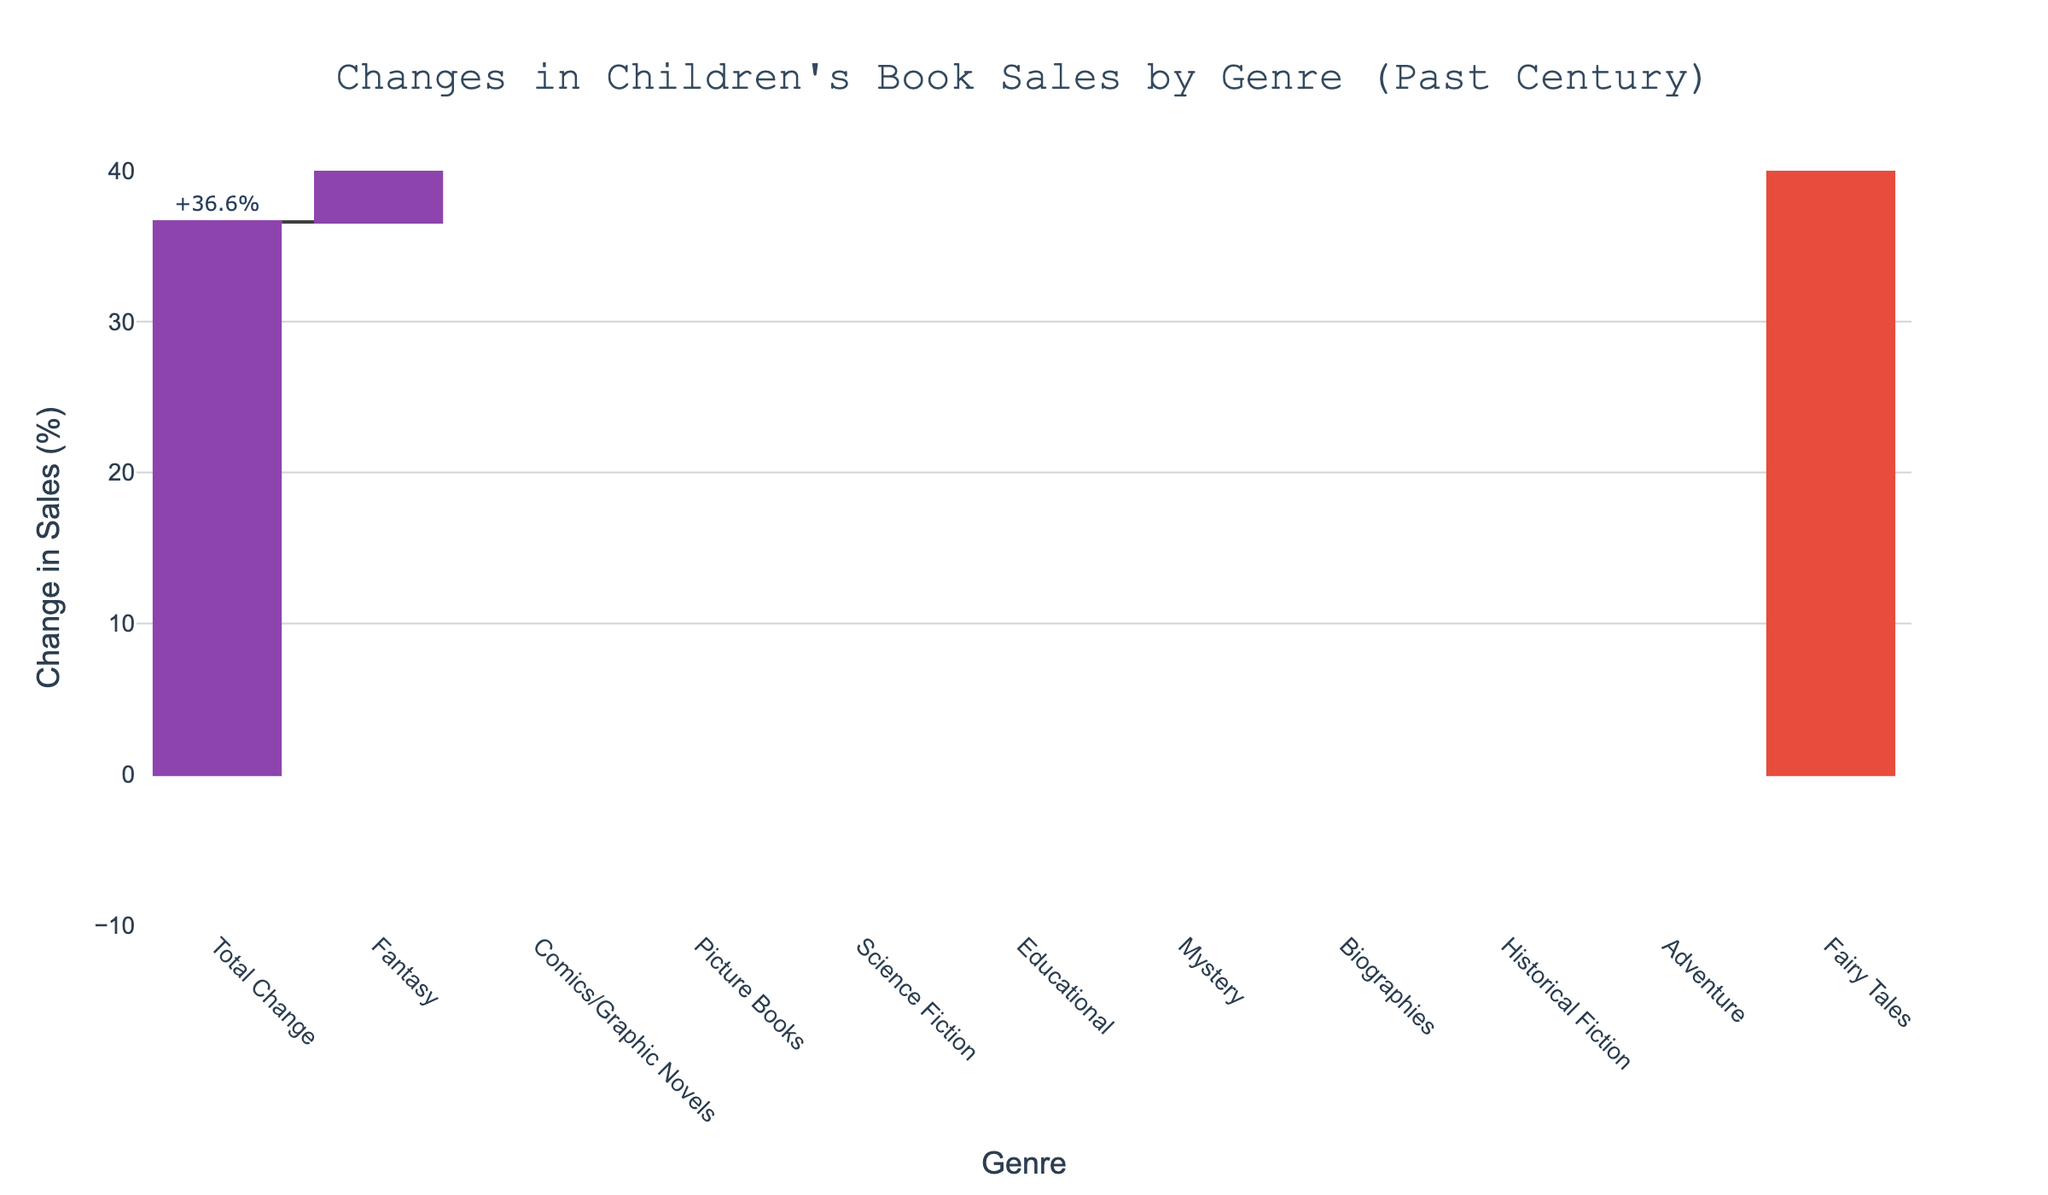What is the title of the figure? The title of the figure is usually found at the top and is the largest text. In this case, it reads "Changes in Children's Book Sales by Genre (Past Century)".
Answer: Changes in Children's Book Sales by Genre (Past Century) Which genre has experienced the greatest increase in sales? By looking at the height of the bars, the genre with the highest positive value represents the greatest increase. Here, "Fantasy" has the highest bar with a +15.2% change.
Answer: Fantasy Which genre has experienced the largest decrease in sales? By inspecting the bars in the downward direction, the genre with the largest negative value indicates the largest decrease. "Fairy Tales" shows the largest decrease with -5.6%.
Answer: Fairy Tales What is the total change in children's book sales across all genres? The total change is usually represented by a different color or a special marker. In this figure, it is marked as "Total +36.6%" which sums up all changes.
Answer: +36.6% How many genres experienced a positive change in sales? Count the number of bars extending upward above the x-axis. There are 7 genres with positive changes: Fantasy, Picture Books, Science Fiction, Comics/Graphic Novels, Educational, Mystery, and Biographies.
Answer: 7 What is the combined change in sales for "Adventure" and "Historical Fiction"? To find the combined change, sum the individual changes for these genres: -3.7 (Adventure) and -2.1 (Historical Fiction). -3.7 + (-2.1) = -5.8
Answer: -5.8% Which had a greater change in sales: "Educational" or "Science Fiction"? Compare the heights of the bars for "Educational" and "Science Fiction". "Science Fiction" has a +6.3% change, whereas "Educational" has a +4.5% change. Thus, "Science Fiction" has a greater change.
Answer: Science Fiction Is the change in sales for "Biographies" positive or negative? Observe the direction of the bar corresponding to "Biographies". It extends slightly below the x-axis indicating a negative change of -1.4%.
Answer: Negative How does the change in "Mystery" compare to the change in "Comics/Graphic Novels"? Look at the bars for both genres. "Mystery" has a +1.8% change and "Comics/Graphic Novels" has a +12.7% change. "Comics/Graphic Novels" has a larger increase.
Answer: Comics/Graphic Novels What’s the average change in sales for the genres that have positive changes? Sum the positive changes: +15.2 (Fantasy) +8.9 (Picture Books) +6.3 (Science Fiction) +12.7 (Comics/Graphic Novels) +4.5 (Educational) +1.8 (Mystery). The sum is 49.4. Divide by the number of positive genres (6), the average change is 49.4 / 6 = 8.23
Answer: 8.23% 